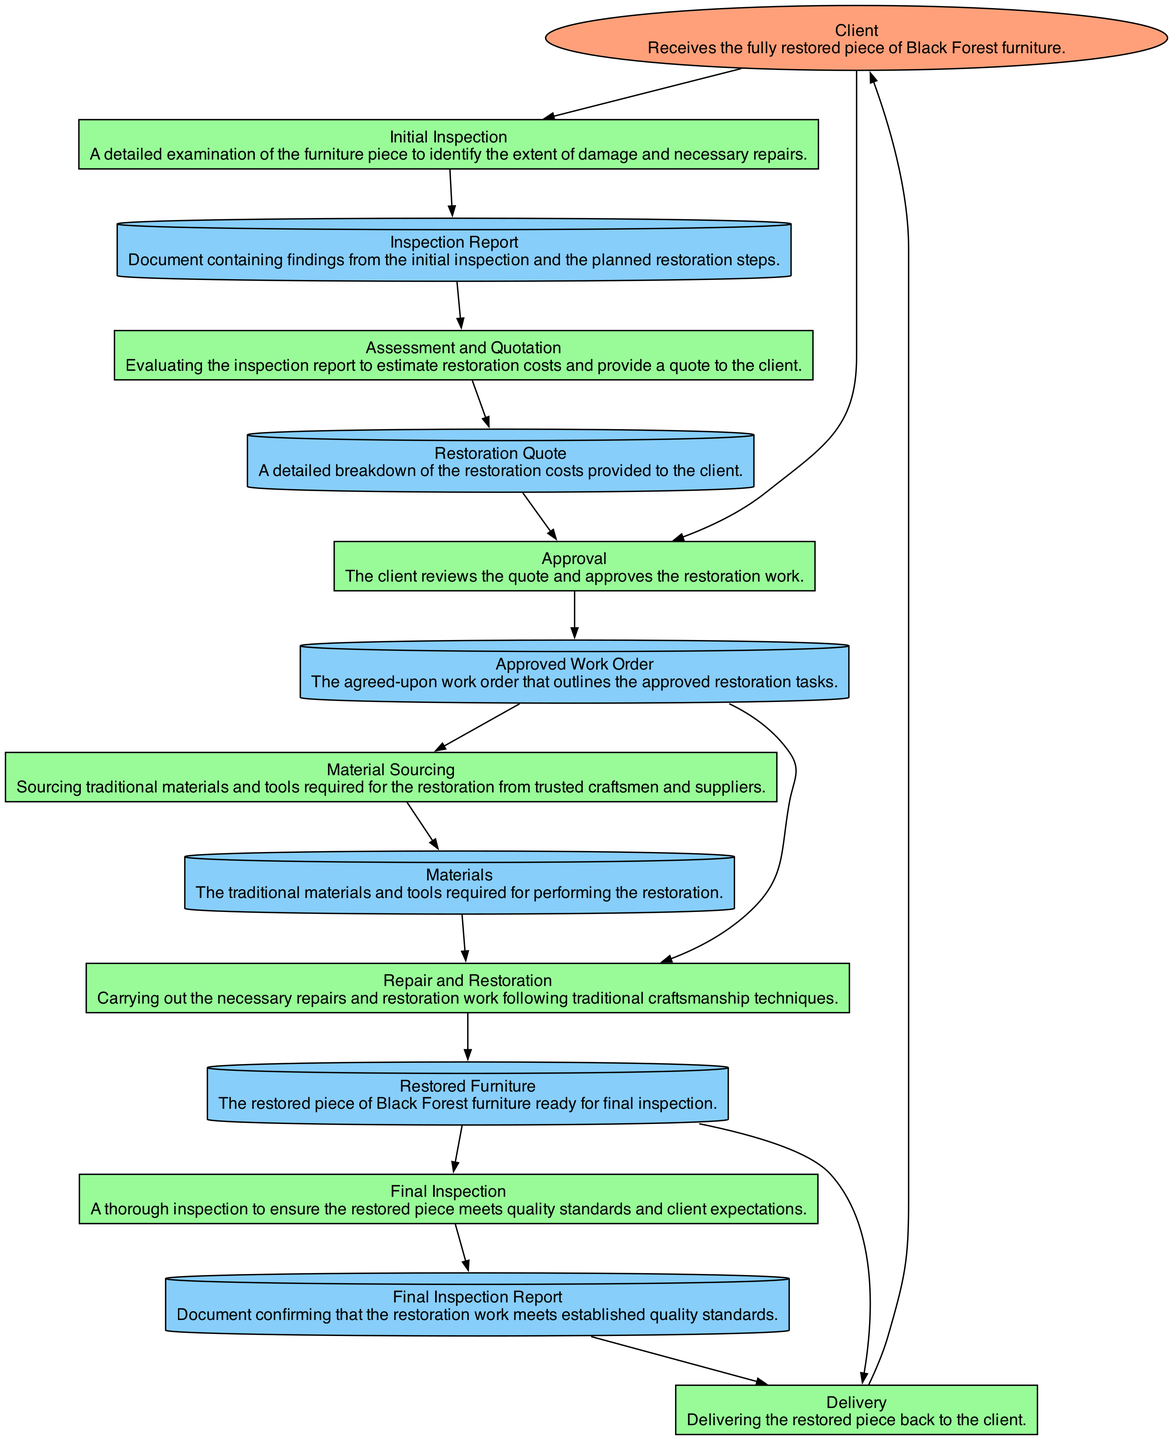What is the first process in the diagram? The diagram starts with the "Initial Inspection" process, which is the first step in restoring the furniture. This is determined by looking at the sequence of processes listed, and "Initial Inspection" appears at the beginning.
Answer: Initial Inspection How many data stores are included in the diagram? The diagram contains five data stores: Inspection Report, Restoration Quote, Approved Work Order, Materials, and Final Inspection Report. Counting the nodes categorized as Data Stores confirms this number.
Answer: Five What is the output of the "Assessment and Quotation" process? The output from the "Assessment and Quotation" process is the "Restoration Quote" which is listed as the output in the diagram. This is identifiable by checking the outputs of the specific process.
Answer: Restoration Quote Which external entity receives the final product? The final product is received by the "Client," who is shown as an external entity that receives the fully restored piece of furniture at the end of the diagram. Confirmed by observing the last connection in the flow.
Answer: Client What materials are needed according to the "Material Sourcing" process? The "Material Sourcing" process outputs "Materials," which indicates that the traditional materials and tools required for restoration are obtained at this stage. This can be understood by reviewing the output of this process directly.
Answer: Materials What must happen before the "Repair and Restoration" process can begin? Before the "Repair and Restoration" process can start, there must be an "Approved Work Order." This is necessary as the input to the repair process indicates the work that has been approved by the client. This sequence clarifies the dependency.
Answer: Approved Work Order Which process follows the "Final Inspection"? The "Delivery" process follows the "Final Inspection." This is evident from the flow of the diagram where the output of "Final Inspection" directly leads to the "Delivery" process.
Answer: Delivery What is the purpose of the "Final Inspection"? The purpose of the "Final Inspection" is to ensure the restored piece meets quality standards and client expectations, as stated specifically in the process description in the diagram. This values the quality assurance step in the restoration process.
Answer: Ensure quality standards What input does the "Approval" process require? The "Approval" process requires two inputs: the "Restoration Quote" and the "Client." This is confirmed by reviewing the input section of the process node in the diagram.
Answer: Restoration Quote and Client 